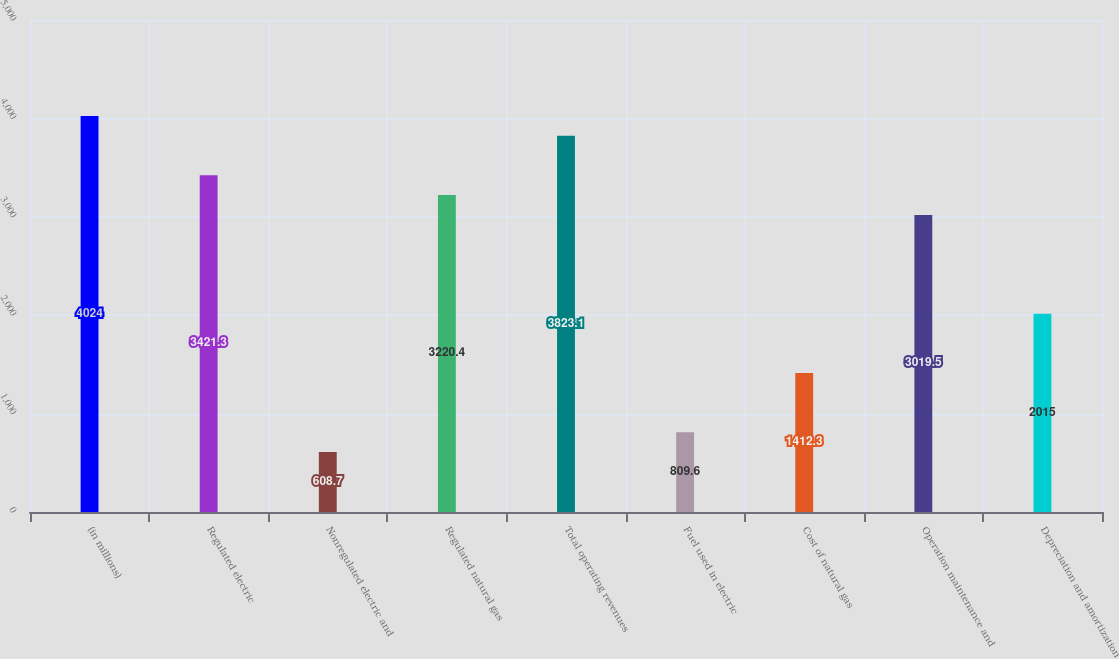Convert chart. <chart><loc_0><loc_0><loc_500><loc_500><bar_chart><fcel>(in millions)<fcel>Regulated electric<fcel>Nonregulated electric and<fcel>Regulated natural gas<fcel>Total operating revenues<fcel>Fuel used in electric<fcel>Cost of natural gas<fcel>Operation maintenance and<fcel>Depreciation and amortization<nl><fcel>4024<fcel>3421.3<fcel>608.7<fcel>3220.4<fcel>3823.1<fcel>809.6<fcel>1412.3<fcel>3019.5<fcel>2015<nl></chart> 